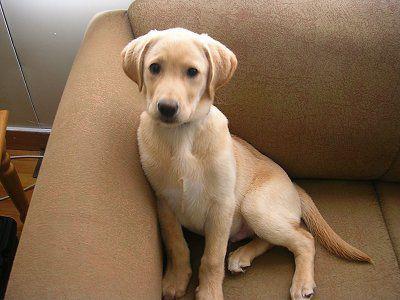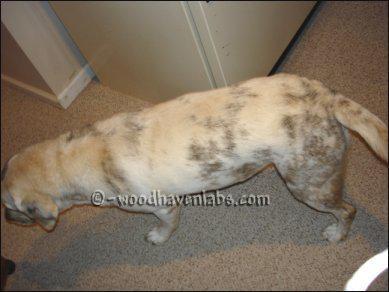The first image is the image on the left, the second image is the image on the right. Given the left and right images, does the statement "A dog has orangish-blond fur and a dark uneven stripe that runs from above one eye to its nose." hold true? Answer yes or no. No. The first image is the image on the left, the second image is the image on the right. For the images displayed, is the sentence "There are more animals in the image on the left." factually correct? Answer yes or no. No. 